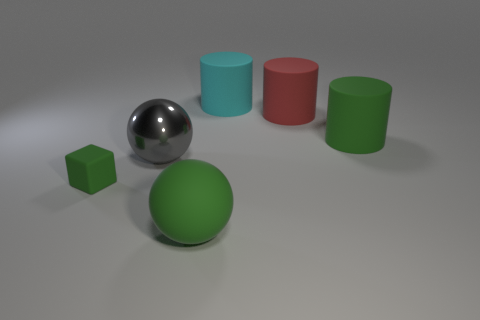There is a rubber sphere that is the same color as the small rubber cube; what is its size?
Offer a very short reply. Large. What number of cylinders are the same color as the large matte ball?
Your answer should be compact. 1. Are there an equal number of cyan rubber things that are right of the red cylinder and cyan objects on the left side of the gray metal object?
Make the answer very short. Yes. What color is the large matte ball?
Offer a very short reply. Green. How many objects are large green objects behind the large metal ball or big gray metal balls?
Offer a very short reply. 2. There is a green rubber object behind the metallic sphere; is it the same size as the green matte object that is on the left side of the large shiny object?
Ensure brevity in your answer.  No. Is there anything else that is the same material as the small cube?
Your answer should be very brief. Yes. How many objects are either large rubber cylinders in front of the large cyan object or big objects that are to the right of the metal thing?
Your response must be concise. 4. Is the material of the large cyan object the same as the large thing that is in front of the tiny green matte block?
Provide a succinct answer. Yes. There is a green rubber object that is on the right side of the tiny green block and in front of the big green cylinder; what is its shape?
Keep it short and to the point. Sphere. 